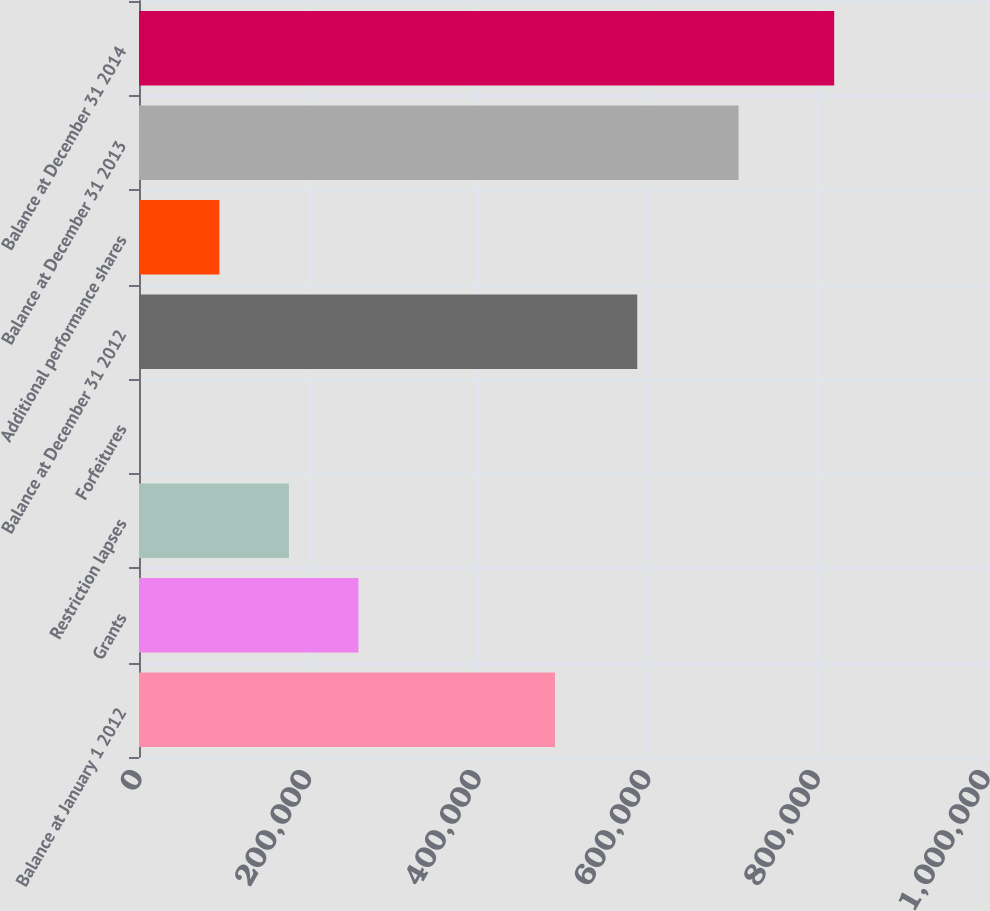<chart> <loc_0><loc_0><loc_500><loc_500><bar_chart><fcel>Balance at January 1 2012<fcel>Grants<fcel>Restriction lapses<fcel>Forfeitures<fcel>Balance at December 31 2012<fcel>Additional performance shares<fcel>Balance at December 31 2013<fcel>Balance at December 31 2014<nl><fcel>490500<fcel>258758<fcel>176779<fcel>2.51<fcel>587550<fcel>94800<fcel>706995<fcel>819790<nl></chart> 